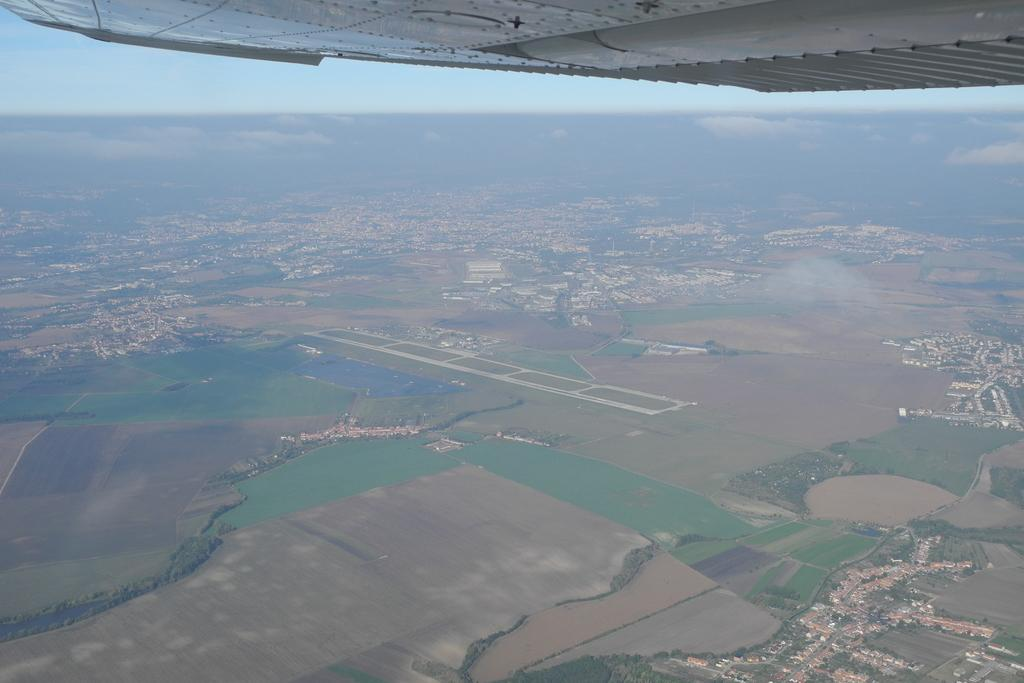What perspective is the image taken from? The image has been taken from a top view. What can be seen in the background of the image? The sky is visible in the background of the image. What type of silk is being used to make the beef in the image? There is no beef or silk present in the image; it only shows a top view with the sky visible in the background. 